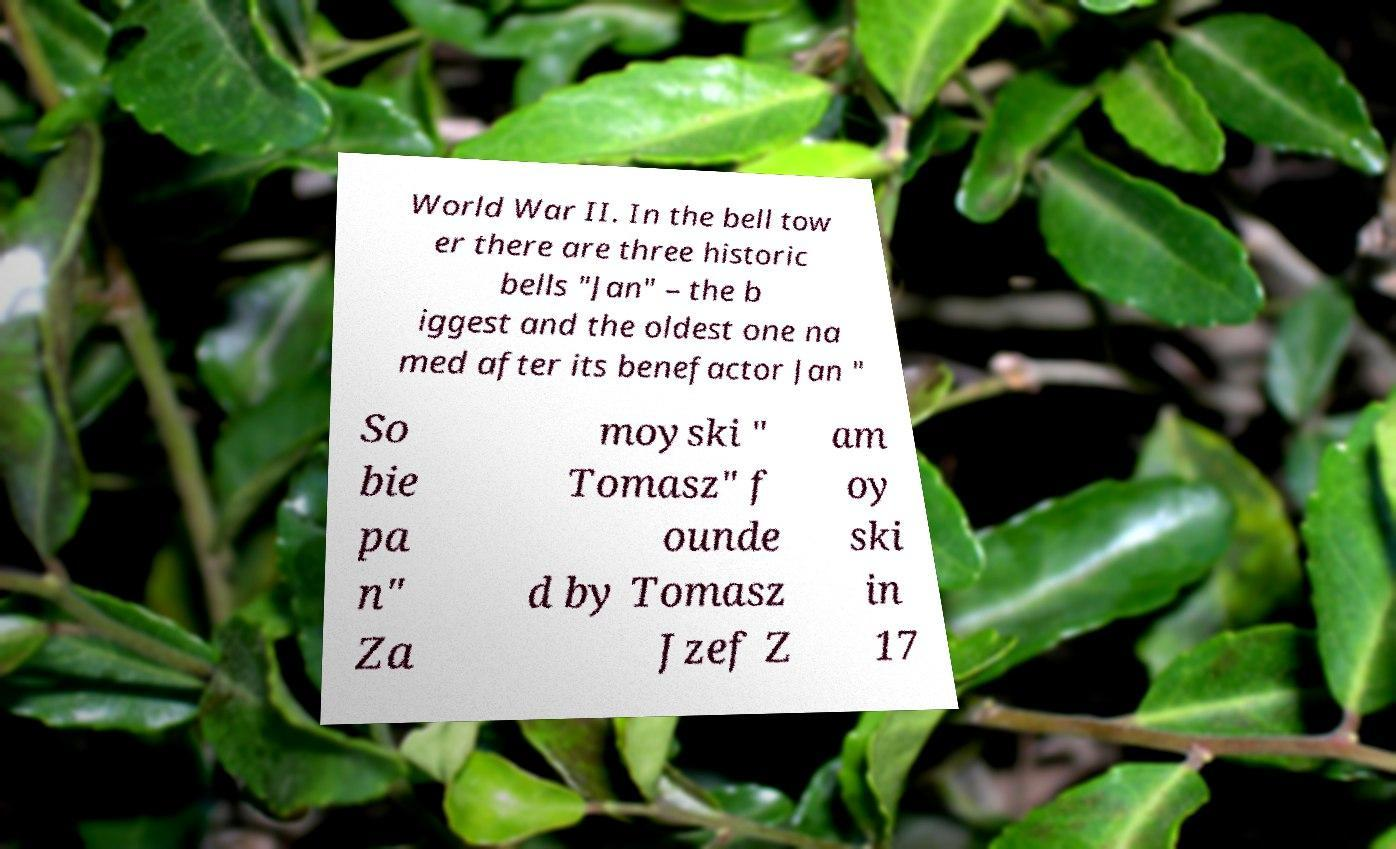Could you assist in decoding the text presented in this image and type it out clearly? World War II. In the bell tow er there are three historic bells "Jan" – the b iggest and the oldest one na med after its benefactor Jan " So bie pa n" Za moyski " Tomasz" f ounde d by Tomasz Jzef Z am oy ski in 17 